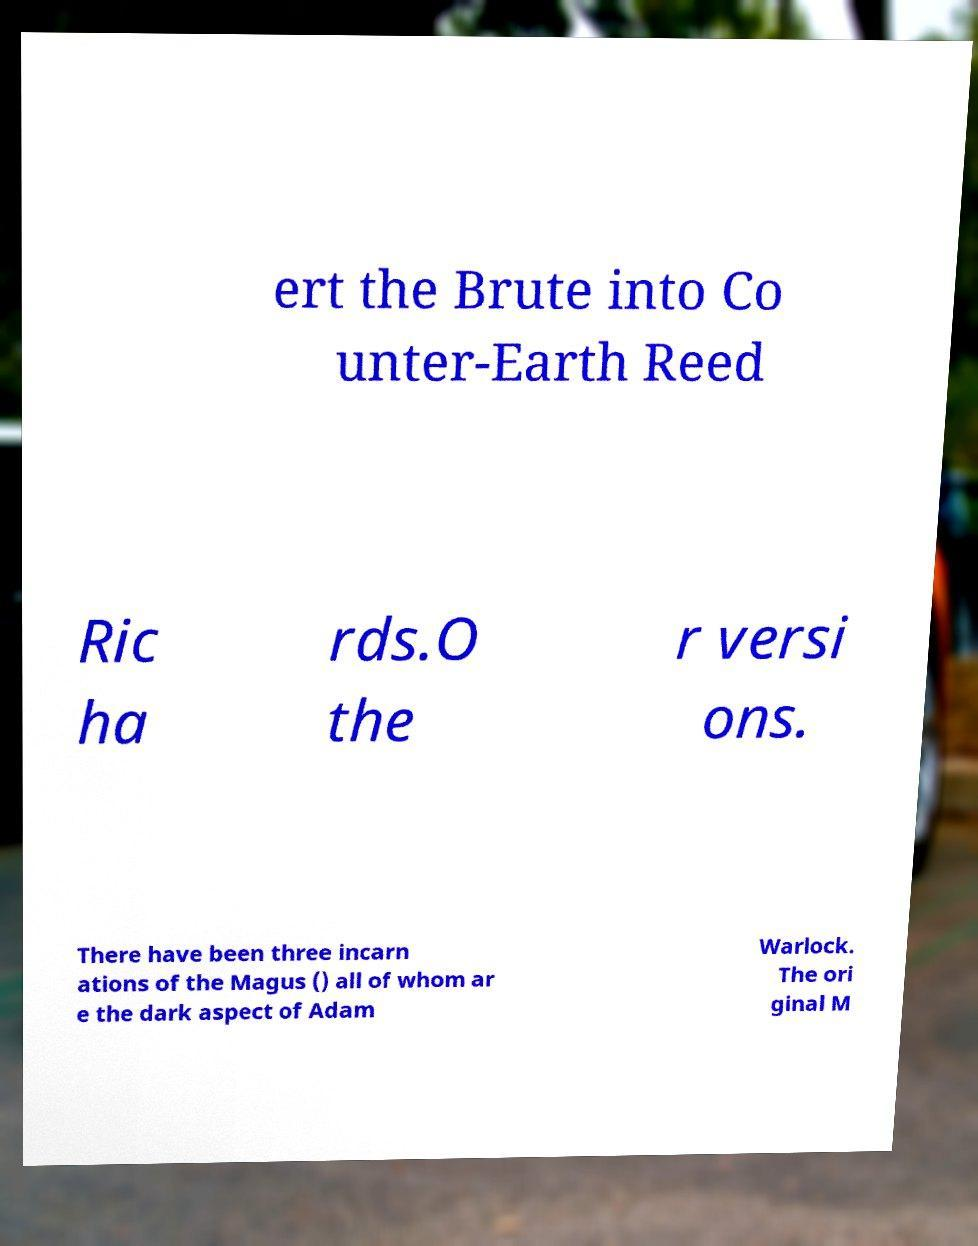Could you assist in decoding the text presented in this image and type it out clearly? ert the Brute into Co unter-Earth Reed Ric ha rds.O the r versi ons. There have been three incarn ations of the Magus () all of whom ar e the dark aspect of Adam Warlock. The ori ginal M 